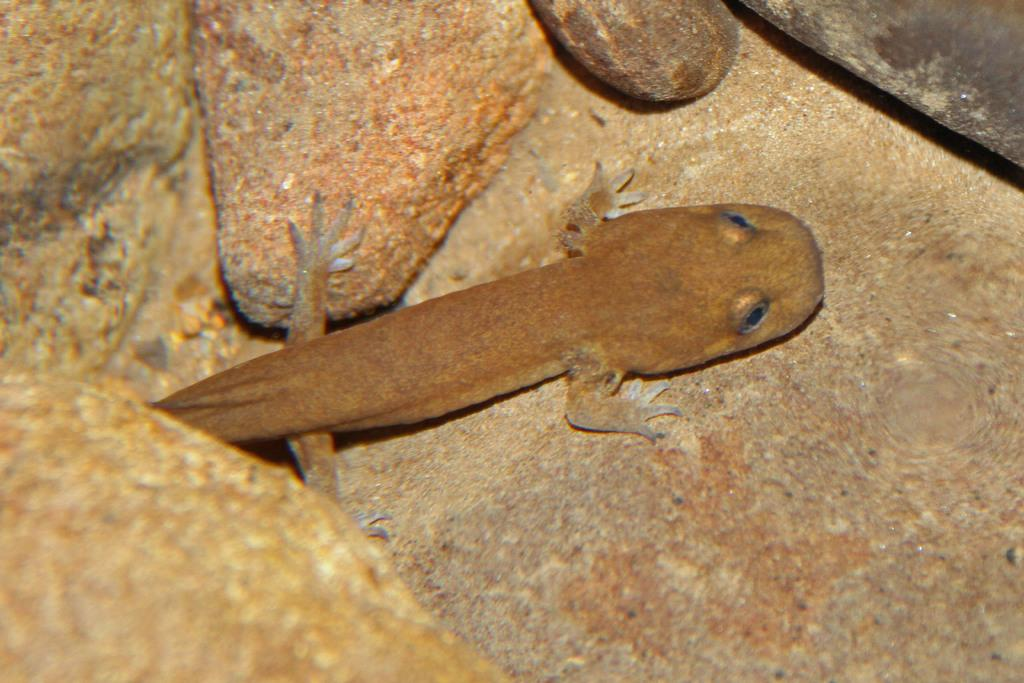What type of animal is present in the image? There is a lizard in the image. Can you describe the lizard's surroundings? The lizard is in between stones. How many branches can be seen in the image? There are no branches visible in the image; it features a lizard in between stones. What type of disease is affecting the mice in the image? There are no mice present in the image, and therefore no disease can be observed. 